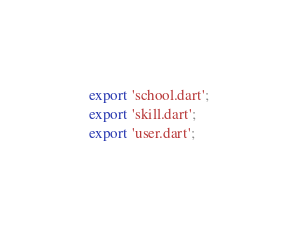<code> <loc_0><loc_0><loc_500><loc_500><_Dart_>export 'school.dart';
export 'skill.dart';
export 'user.dart';</code> 